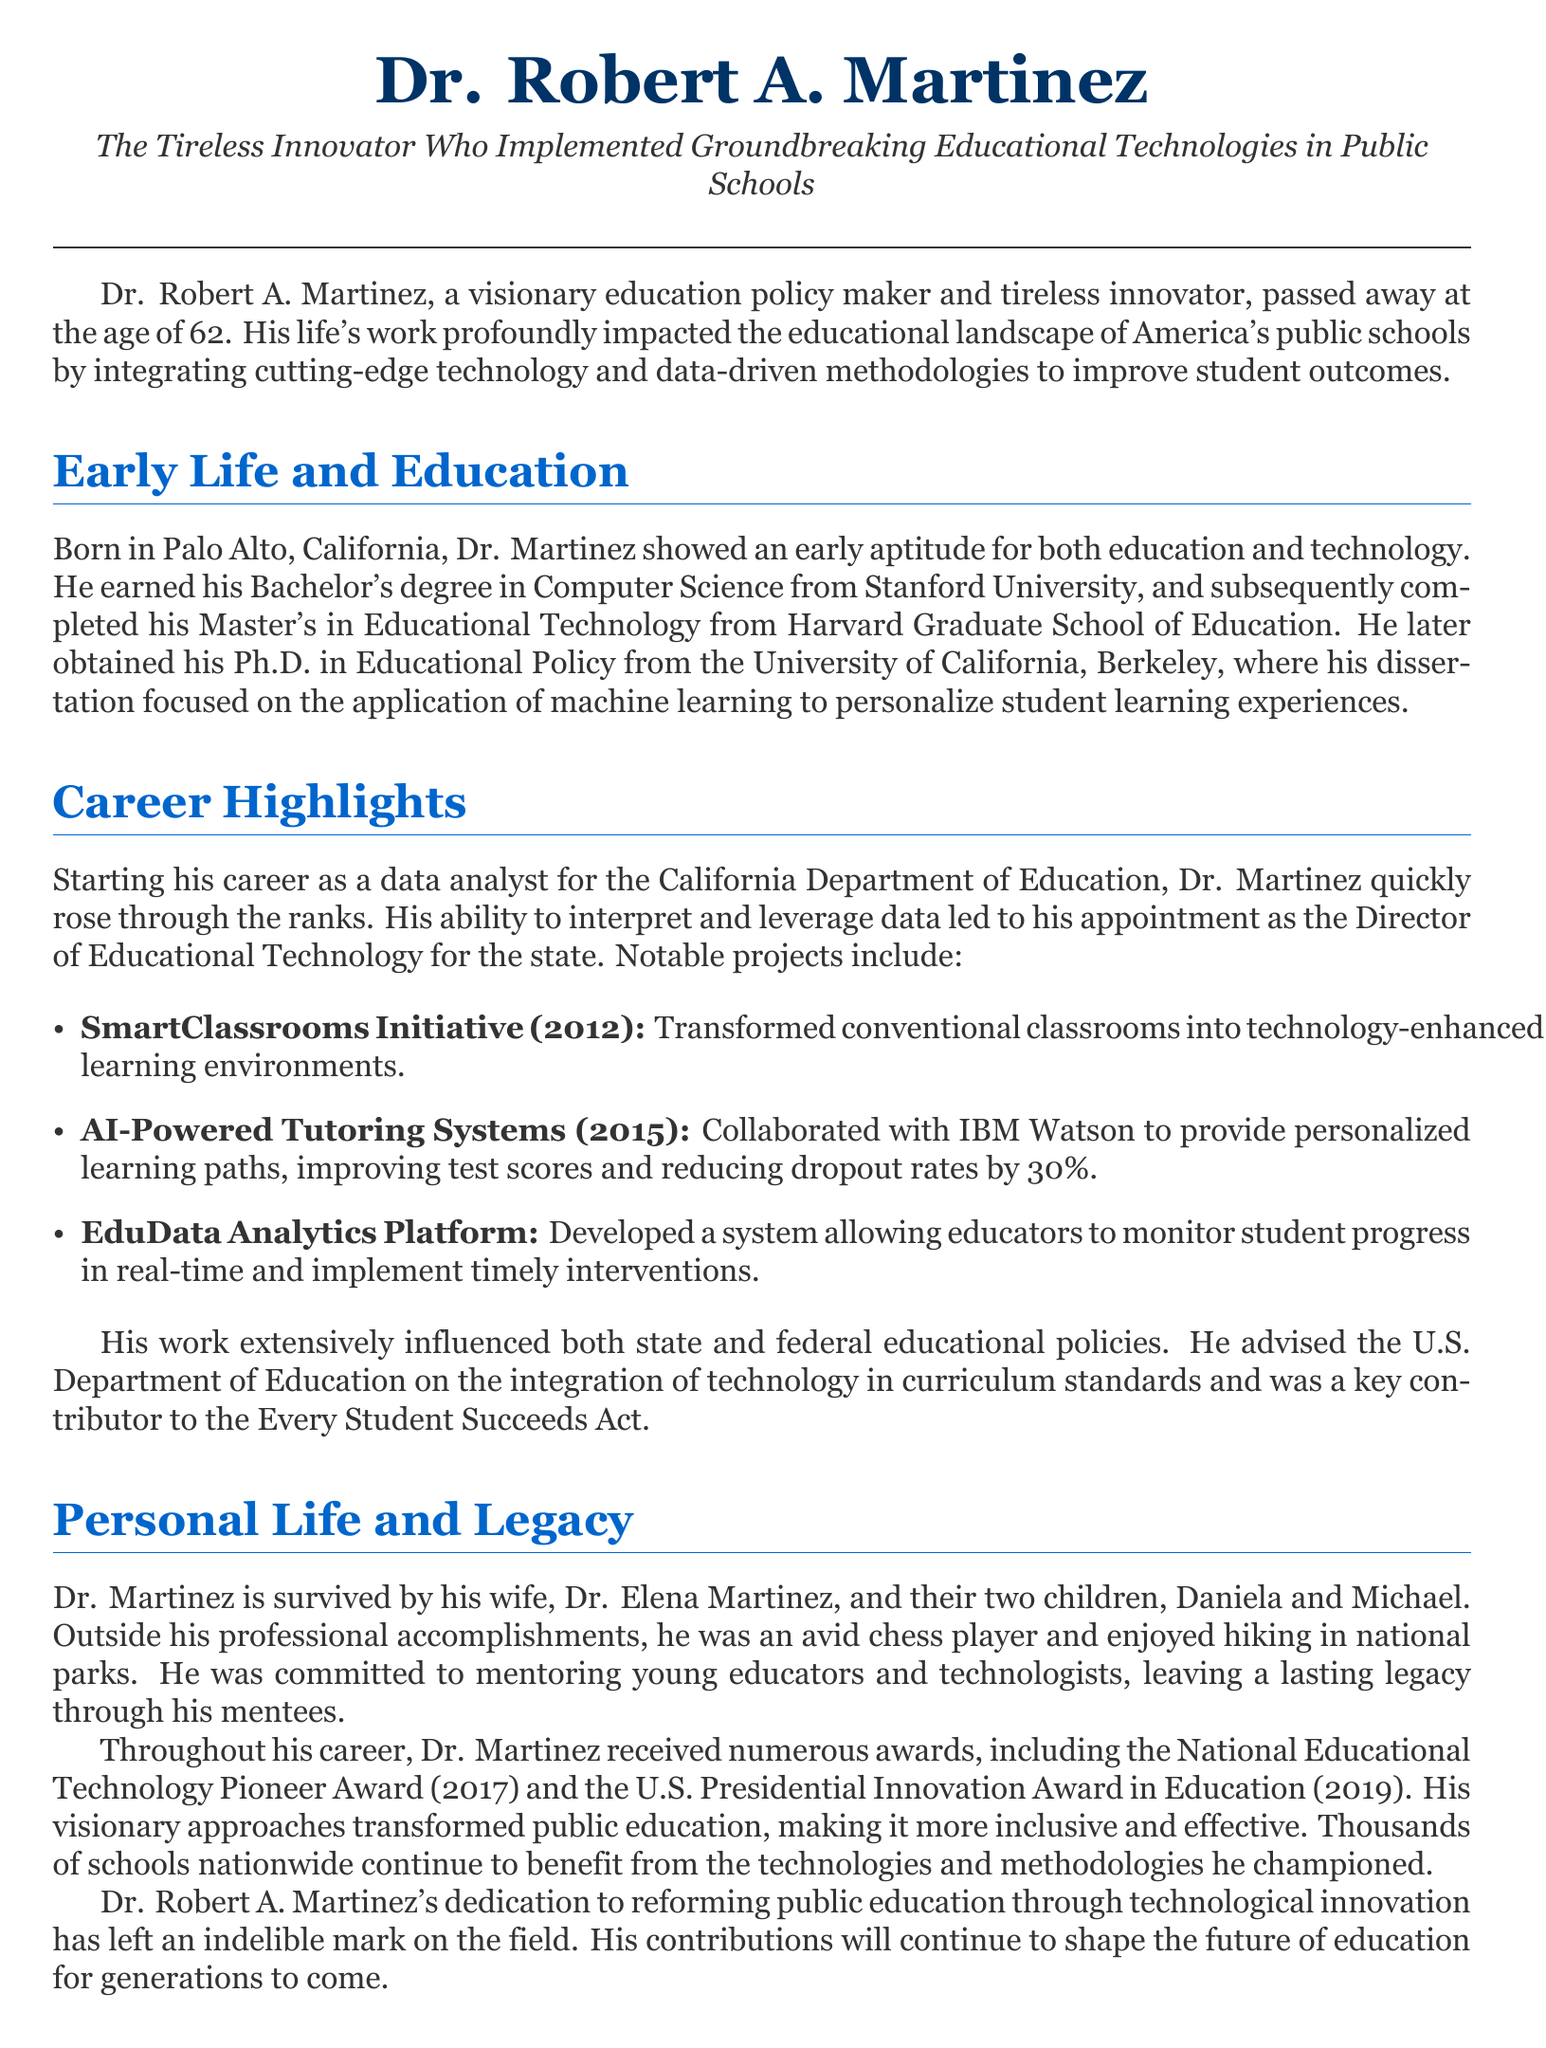What was Dr. Martinez's age at the time of his passing? The document states that Dr. Robert A. Martinez passed away at the age of 62.
Answer: 62 What degree did Dr. Martinez obtain from Stanford University? The document mentions that Dr. Martinez earned his Bachelor's degree in Computer Science from Stanford University.
Answer: Computer Science What initiative did Dr. Martinez implement in 2012? The text describes the SmartClassrooms Initiative as a notable project implemented by Dr. Martinez in 2012.
Answer: SmartClassrooms Initiative Which award did Dr. Martinez receive in 2019? According to the document, Dr. Martinez received the U.S. Presidential Innovation Award in Education in 2019.
Answer: U.S. Presidential Innovation Award in Education What technology did Dr. Martinez collaborate with IBM Watson to develop? The document notes that Dr. Martinez worked on AI-Powered Tutoring Systems in collaboration with IBM Watson.
Answer: AI-Powered Tutoring Systems Which state did Dr. Martinez work as a data analyst? The document states Dr. Martinez started his career as a data analyst for the California Department of Education.
Answer: California What was the main focus of Dr. Martinez's dissertation? The document indicates that his dissertation focused on the application of machine learning to personalize student learning experiences.
Answer: Machine learning What personal hobby did Dr. Martinez enjoy outside of work? The text notes that Dr. Martinez was an avid chess player outside his professional accomplishments.
Answer: Chess How many children did Dr. Martinez have? The document mentions that Dr. Martinez is survived by his two children, Daniela and Michael.
Answer: Two 